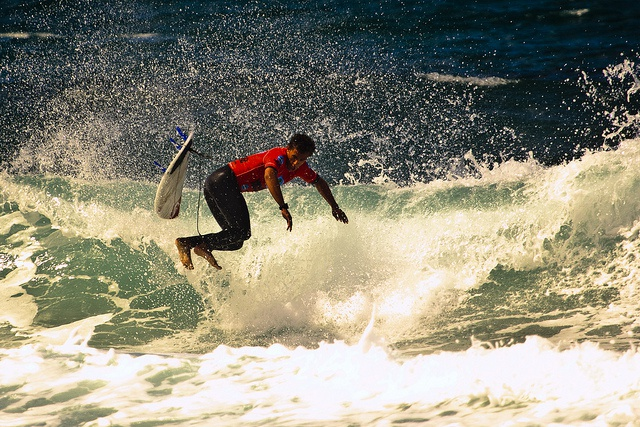Describe the objects in this image and their specific colors. I can see people in black, maroon, khaki, and gray tones and surfboard in black, gray, and tan tones in this image. 